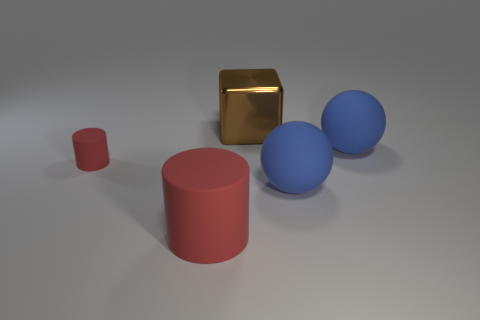What time of the day or lighting conditions does this setting seem to represent? Judging by the soft shadows and the neutral background, this setting probably represents an indoor scene with artificial lighting. It gives the impression of being in a studio where objects are evenly lit to minimize harsh shadows, which might suggest a controlled lighting situation often used in product photography or 3D rendering. 